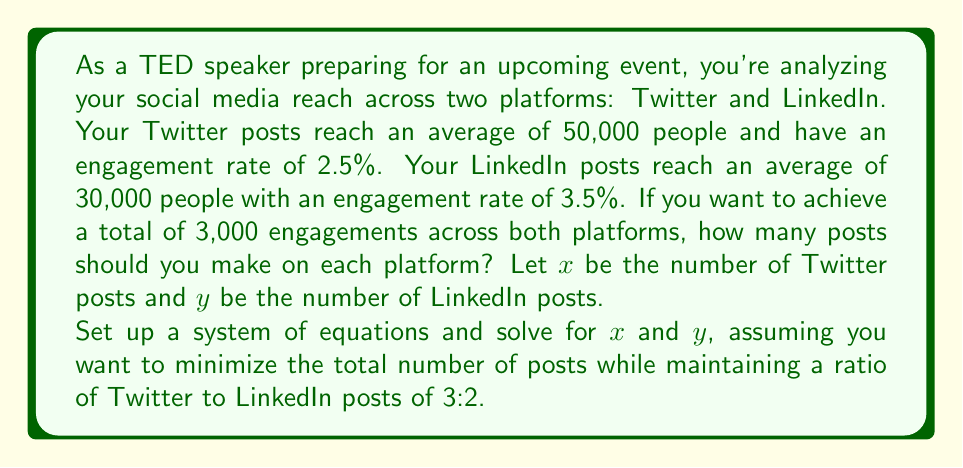Can you solve this math problem? Let's approach this step-by-step:

1) First, let's set up an equation for the total engagements:
   $$50000 \cdot 0.025x + 30000 \cdot 0.035y = 3000$$
   This simplifies to:
   $$1250x + 1050y = 3000 \quad (1)$$

2) Next, we need to express the ratio of Twitter to LinkedIn posts:
   $$\frac{x}{y} = \frac{3}{2}$$
   This can be rewritten as:
   $$2x = 3y \quad (2)$$

3) Now we have a system of two equations with two unknowns. Let's solve it by substitution.

4) From equation (2), we can express $x$ in terms of $y$:
   $$x = \frac{3y}{2}$$

5) Substitute this into equation (1):
   $$1250(\frac{3y}{2}) + 1050y = 3000$$
   $$1875y + 1050y = 3000$$
   $$2925y = 3000$$
   $$y = \frac{3000}{2925} \approx 1.03$$

6) Since we need whole numbers of posts, we round up to $y = 2$ LinkedIn posts.

7) Substituting back into equation (2):
   $$2x = 3(2)$$
   $$x = 3$$ Twitter posts

8) Let's verify:
   Twitter engagements: $50000 \cdot 0.025 \cdot 3 = 3750$
   LinkedIn engagements: $30000 \cdot 0.035 \cdot 2 = 2100$
   Total: $3750 + 2100 = 5850$, which exceeds our goal of 3000 engagements.
Answer: You should make 3 posts on Twitter and 2 posts on LinkedIn to achieve your engagement goal while maintaining the desired ratio. 